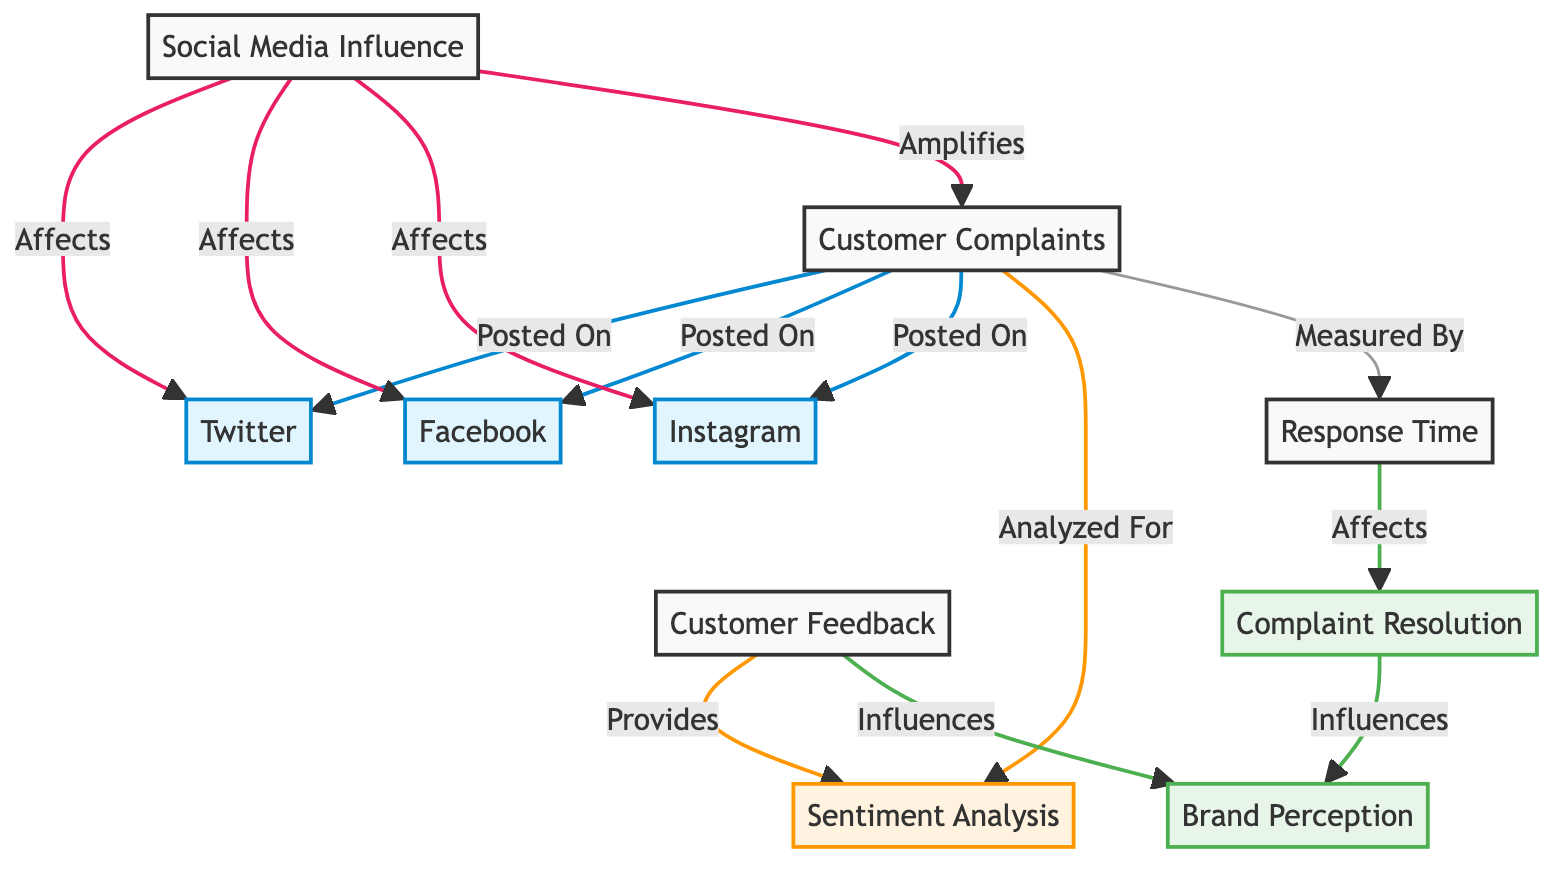What are the three social media platforms where customer complaints are posted? The diagram shows three edges leading from "Customer Complaints" to the nodes "Twitter," "Facebook," and "Instagram." These connections indicate that customer complaints are posted on these three platforms.
Answer: Twitter, Facebook, Instagram How many nodes are there in the diagram? By counting the entries in the "nodes" section of the data, we can identify the total number of unique nodes present in the diagram, which amounts to ten nodes in total.
Answer: 10 What does customer feedback provide for sentiment analysis? The diagram shows a connection from "Customer Feedback" to "Sentiment Analysis," indicating that customer feedback is used to provide data for sentiment analysis.
Answer: Provides Which social media platform has the strongest influence noted in the diagram? The term "Affects" is used multiple times in relation to "Social Media Influence" impacting "Twitter," "Facebook," and "Instagram." Since they are all connected and the diagram does not differentiate strength, we conclude that all three have equal influence described as affecting them.
Answer: Twitter, Facebook, Instagram What affects complaint resolution according to the diagram? The edges in the diagram indicate that "Response Time" is linked to "Complaint Resolution," with the label showing that response time affects how well complaints are resolved.
Answer: Response Time How many edges are there in total connecting the nodes? By counting all the connections defined in the "edges" section, we find that there are a total of twelve connections linking the various nodes in the diagram.
Answer: 12 Which node influences brand perception? The diagram reveals three connections: one from "Customer Feedback" and another from "Complaint Resolution" that directly indicate that both these nodes have an influence on "Brand Perception."
Answer: Customer Feedback, Complaint Resolution What is amplified by social media influence in the diagram? The diagram explicitly states that "Social Media Influence" amplifies "Customer Complaints," which suggests that the presence and activity on social media platforms increase the visibility and impact of customer complaints.
Answer: Customer Complaints What relationship do response time and complaint resolution have? The diagram shows a connection labeled "Affects" from "Response Time" to "Complaint Resolution," thus establishing a direct relationship where the response time impacts the resolution of complaints.
Answer: Affects 